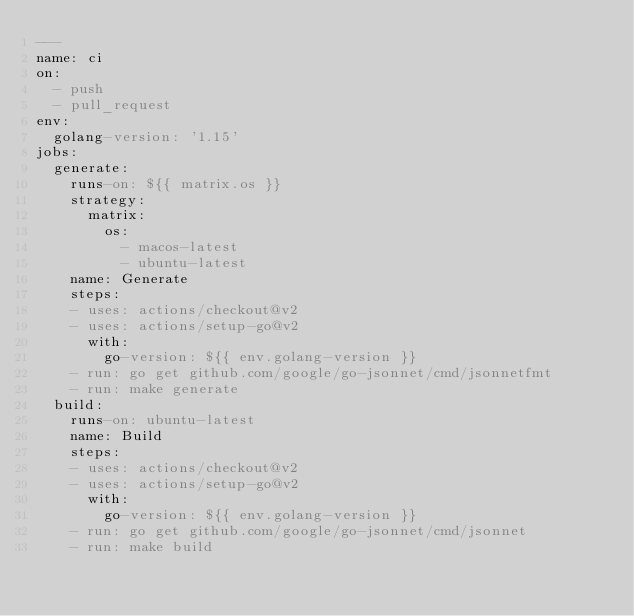Convert code to text. <code><loc_0><loc_0><loc_500><loc_500><_YAML_>---
name: ci
on:
  - push
  - pull_request
env:
  golang-version: '1.15'
jobs:
  generate:
    runs-on: ${{ matrix.os }}
    strategy:
      matrix:
        os:
          - macos-latest
          - ubuntu-latest
    name: Generate
    steps:
    - uses: actions/checkout@v2
    - uses: actions/setup-go@v2
      with:
        go-version: ${{ env.golang-version }}
    - run: go get github.com/google/go-jsonnet/cmd/jsonnetfmt
    - run: make generate
  build:
    runs-on: ubuntu-latest
    name: Build
    steps:
    - uses: actions/checkout@v2
    - uses: actions/setup-go@v2
      with:
        go-version: ${{ env.golang-version }}
    - run: go get github.com/google/go-jsonnet/cmd/jsonnet
    - run: make build
</code> 